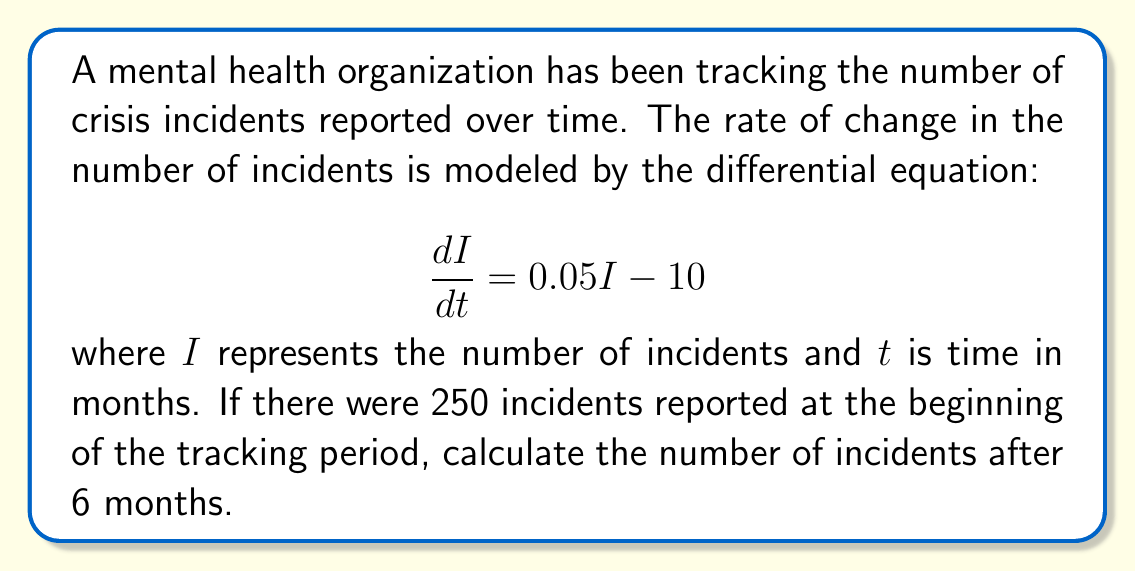Can you solve this math problem? To solve this problem, we need to follow these steps:

1) First, we recognize this as a first-order linear differential equation in the form:

   $$\frac{dI}{dt} = aI + b$$

   where $a = 0.05$ and $b = -10$

2) The general solution for this type of equation is:

   $$I(t) = Ce^{at} - \frac{b}{a}$$

   where $C$ is a constant we need to determine from the initial condition.

3) Substituting our values:

   $$I(t) = Ce^{0.05t} + 200$$

4) We use the initial condition to find $C$:
   At $t = 0$, $I = 250$

   $$250 = C + 200$$
   $$C = 50$$

5) Now our specific solution is:

   $$I(t) = 50e^{0.05t} + 200$$

6) To find the number of incidents after 6 months, we substitute $t = 6$:

   $$I(6) = 50e^{0.05(6)} + 200$$
   $$I(6) = 50e^{0.3} + 200$$
   $$I(6) = 50(1.34986) + 200$$
   $$I(6) = 67.493 + 200$$
   $$I(6) = 267.493$$

7) Rounding to the nearest whole number (as we can't have fractional incidents):

   $$I(6) \approx 267$$
Answer: After 6 months, there will be approximately 267 incidents. 